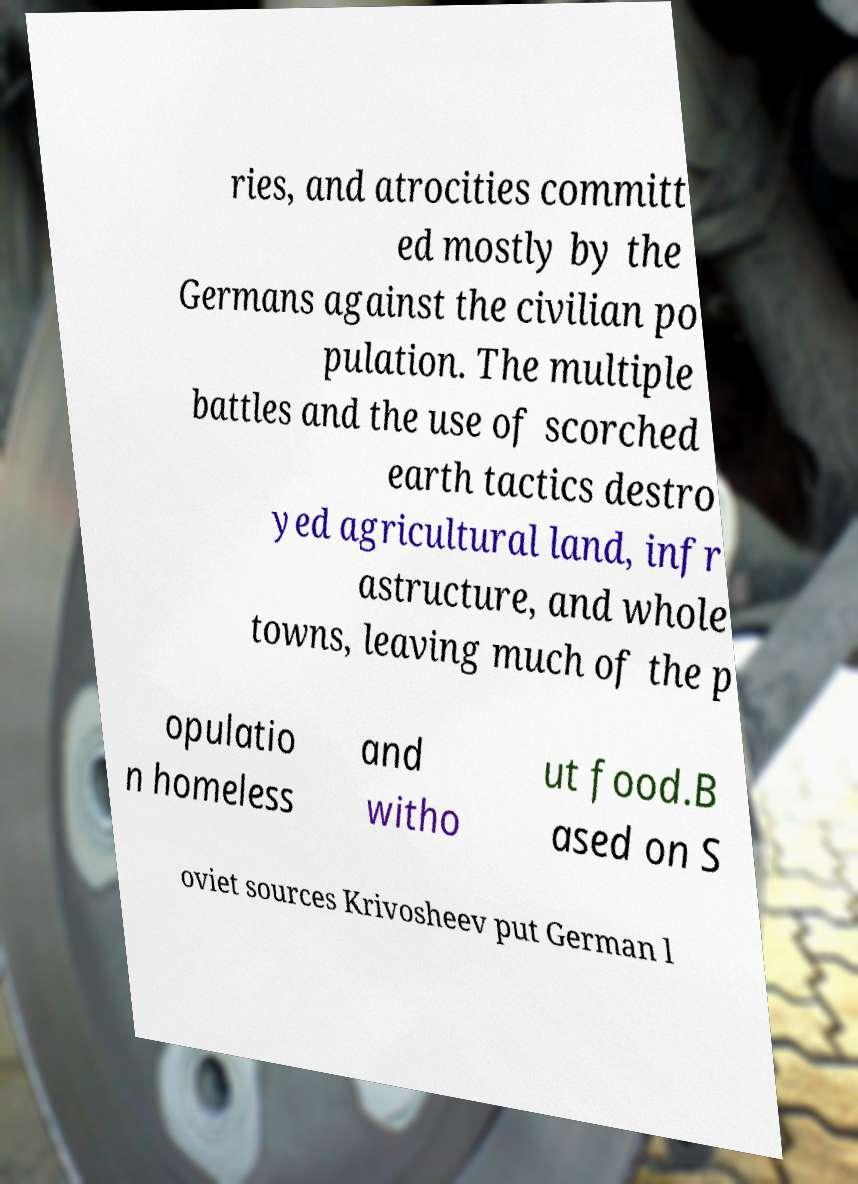Can you read and provide the text displayed in the image?This photo seems to have some interesting text. Can you extract and type it out for me? ries, and atrocities committ ed mostly by the Germans against the civilian po pulation. The multiple battles and the use of scorched earth tactics destro yed agricultural land, infr astructure, and whole towns, leaving much of the p opulatio n homeless and witho ut food.B ased on S oviet sources Krivosheev put German l 